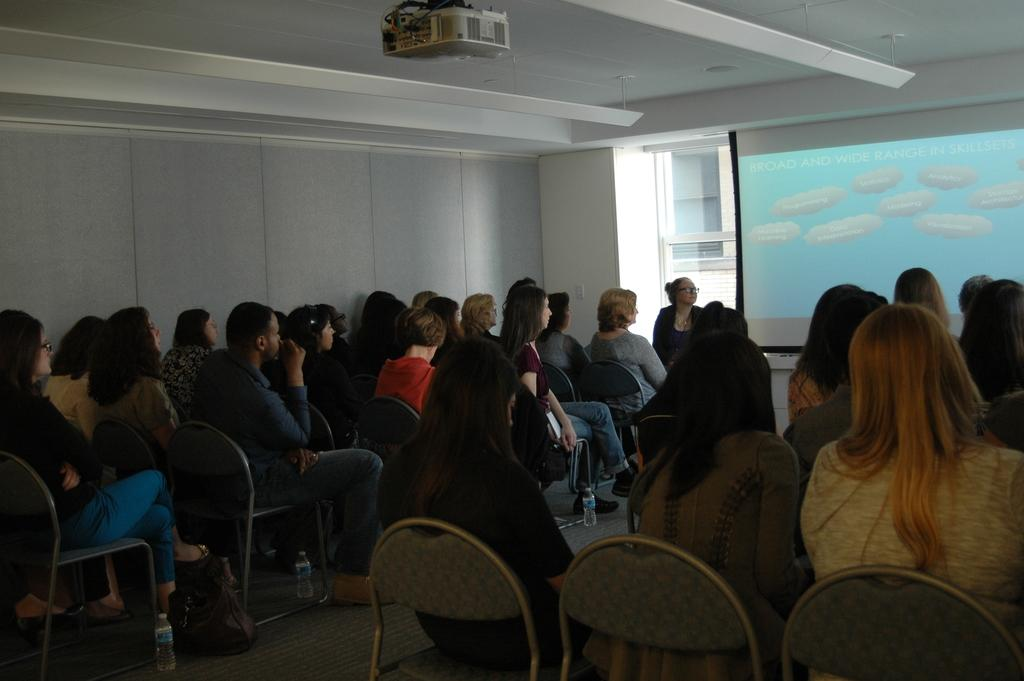How many people are in the image? There are many people in the image. What are the people doing in the image? The people are sitting on a row. What are the people looking at in the image? The people are looking at a projector screen. Where is the projector screen located in the image? The projector screen is hanging from the wall. What type of song is being played in the image? There is no mention of a song being played in the image. Can you tell me how many doors are visible in the image? There is no door visible in the image; it focuses on the people, their actions, and the projector screen. 